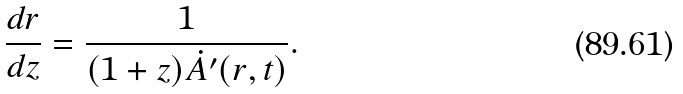Convert formula to latex. <formula><loc_0><loc_0><loc_500><loc_500>\frac { d r } { d z } = \frac { 1 } { ( 1 + z ) \dot { A } ^ { \prime } ( r , t ) } .</formula> 